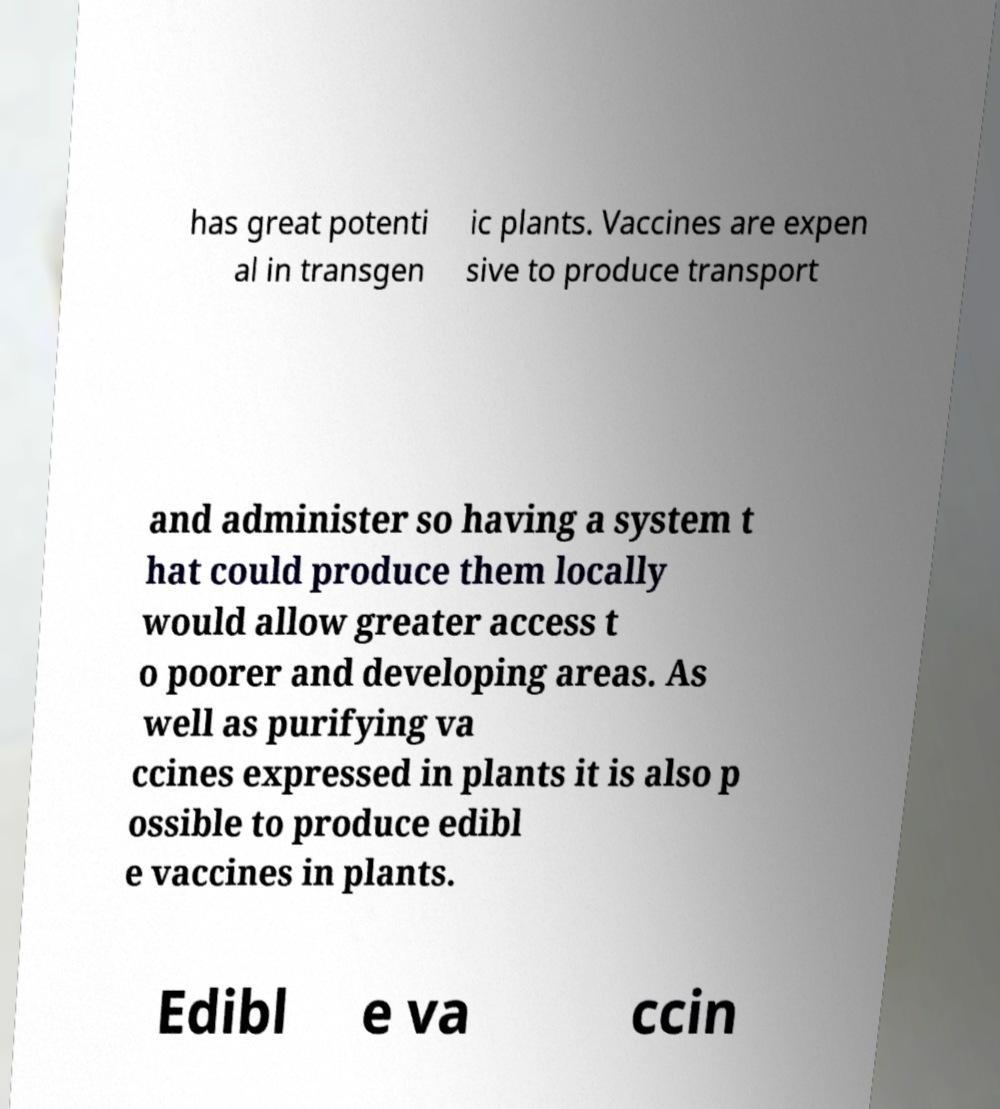I need the written content from this picture converted into text. Can you do that? has great potenti al in transgen ic plants. Vaccines are expen sive to produce transport and administer so having a system t hat could produce them locally would allow greater access t o poorer and developing areas. As well as purifying va ccines expressed in plants it is also p ossible to produce edibl e vaccines in plants. Edibl e va ccin 